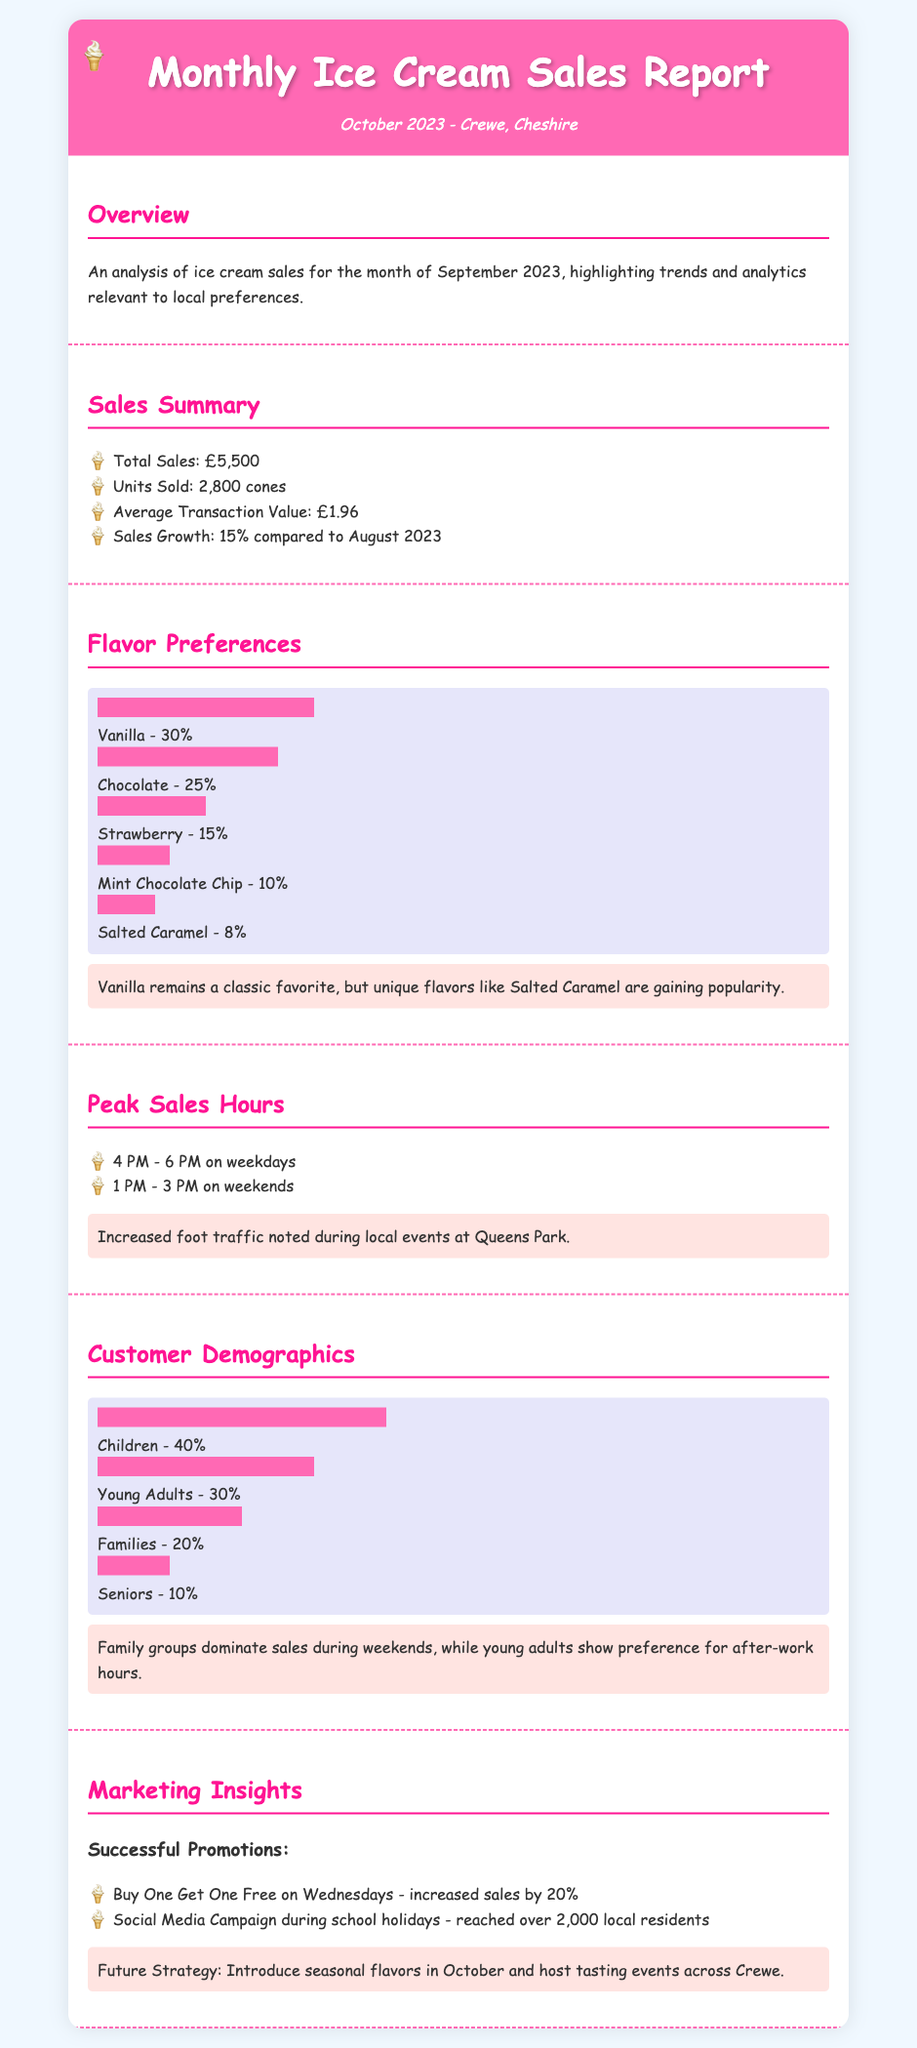What is the total sales amount? The total sales amount is indicated in the Sales Summary section.
Answer: £5,500 What is the average transaction value? The average transaction value is mentioned in the Sales Summary section.
Answer: £1.96 Which flavor has the highest sales percentage? The flavor preferences section lists sales percentages for each flavor.
Answer: Vanilla What time frame sees peak sales on weekdays? The peak sales hours section provides time frames for weekdays.
Answer: 4 PM - 6 PM What percentage of sales is from children? The customer demographics section states the percentage of sales from different age groups.
Answer: 40% What promotional strategy increased sales by 20%? Marketing insights section highlights effective promotions and their impact.
Answer: Buy One Get One Free on Wednesdays Which demographic group shows a preference for after-work hours? The customer demographics section discusses the habits of different groups.
Answer: Young Adults What flavor is gaining popularity according to the report? The Flavor Preferences section provides insights into trending flavors.
Answer: Salted Caramel What was the sales growth compared to August 2023? The sales summary section compares performance from the previous month.
Answer: 15% 